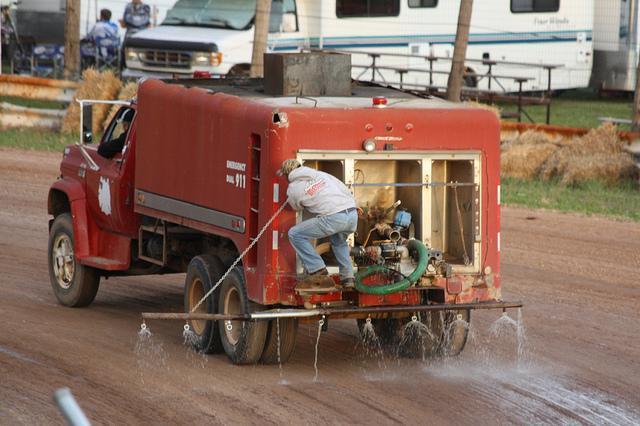How many trucks are there?
Give a very brief answer. 2. 